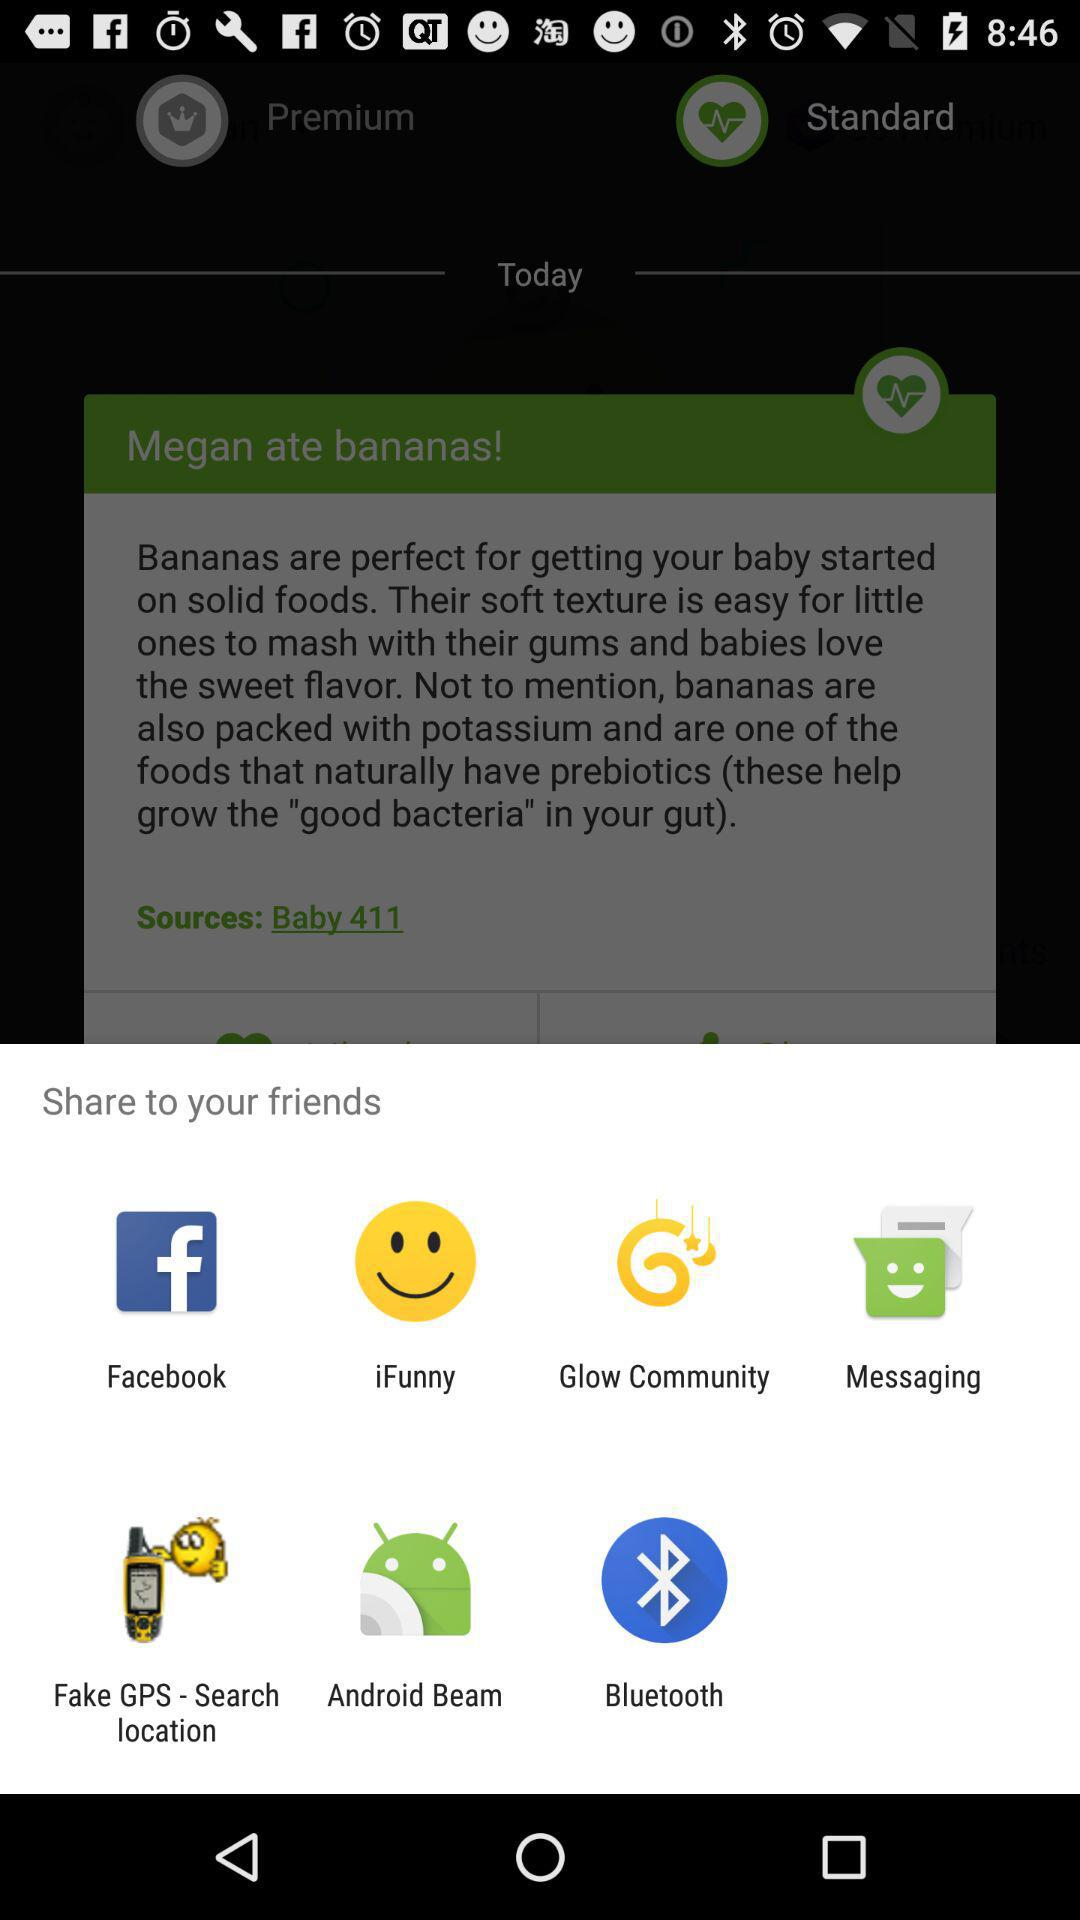How much does premium cost?
When the provided information is insufficient, respond with <no answer>. <no answer> 